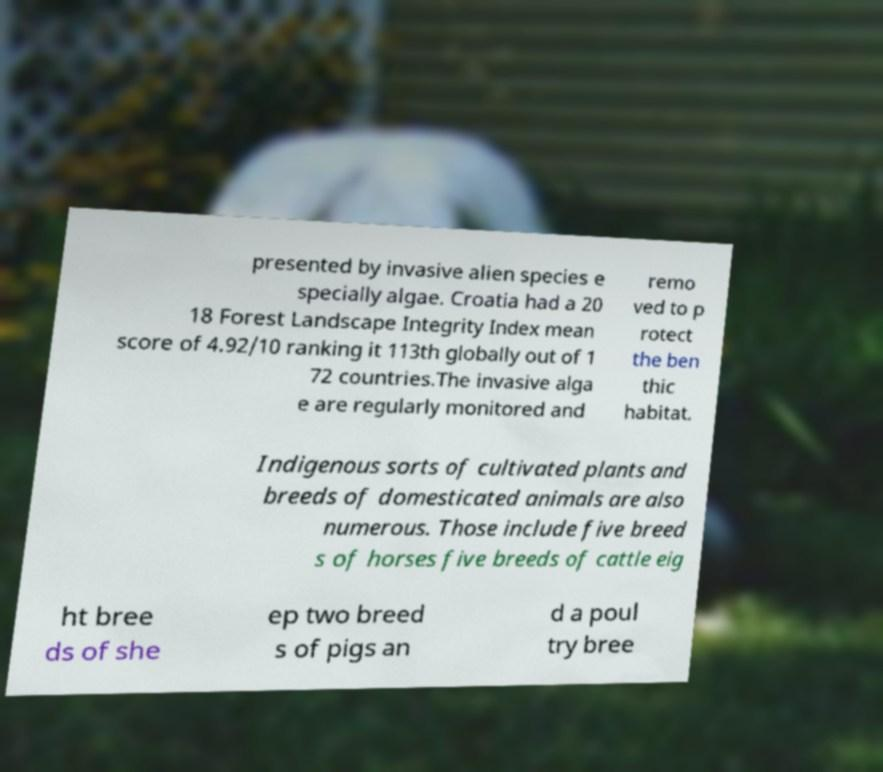What messages or text are displayed in this image? I need them in a readable, typed format. presented by invasive alien species e specially algae. Croatia had a 20 18 Forest Landscape Integrity Index mean score of 4.92/10 ranking it 113th globally out of 1 72 countries.The invasive alga e are regularly monitored and remo ved to p rotect the ben thic habitat. Indigenous sorts of cultivated plants and breeds of domesticated animals are also numerous. Those include five breed s of horses five breeds of cattle eig ht bree ds of she ep two breed s of pigs an d a poul try bree 